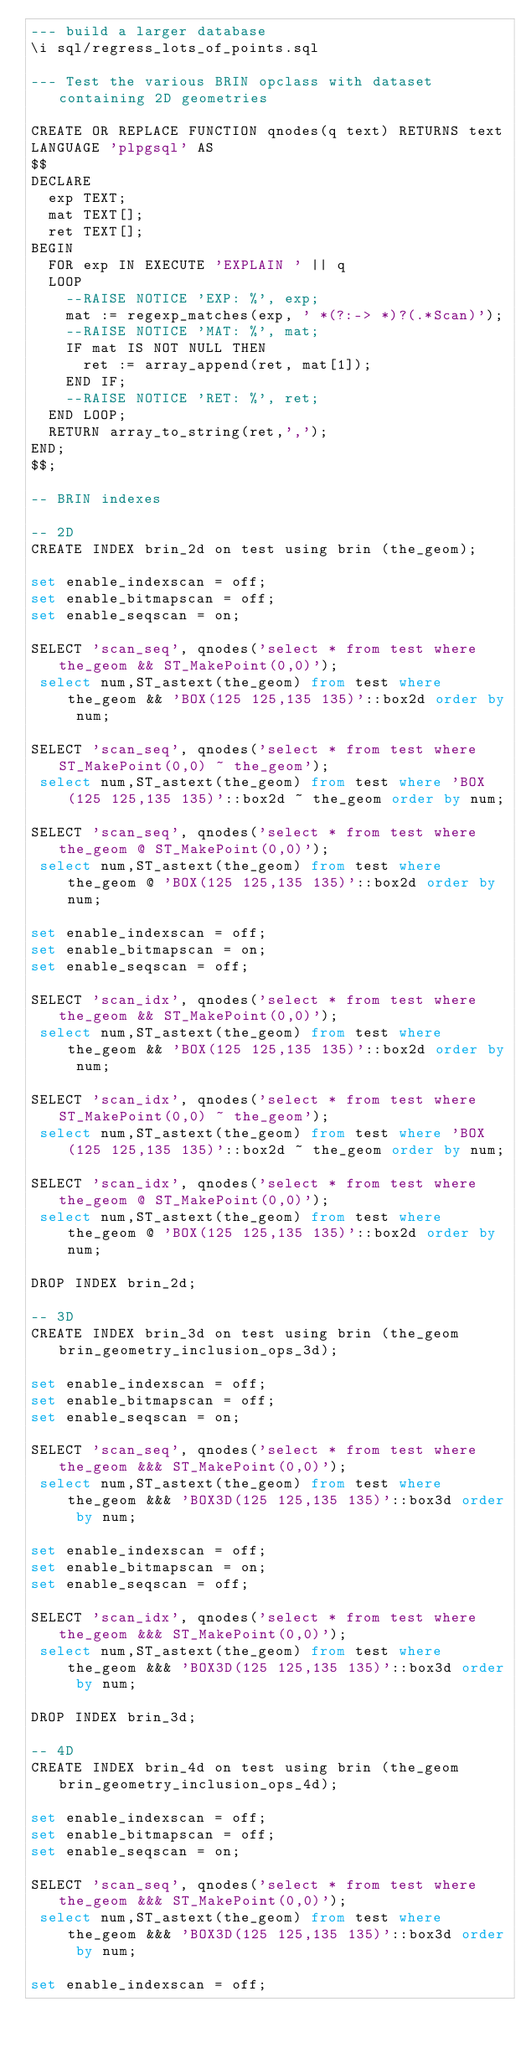<code> <loc_0><loc_0><loc_500><loc_500><_SQL_>--- build a larger database
\i sql/regress_lots_of_points.sql

--- Test the various BRIN opclass with dataset containing 2D geometries

CREATE OR REPLACE FUNCTION qnodes(q text) RETURNS text
LANGUAGE 'plpgsql' AS
$$
DECLARE
  exp TEXT;
  mat TEXT[];
  ret TEXT[];
BEGIN
  FOR exp IN EXECUTE 'EXPLAIN ' || q
  LOOP
    --RAISE NOTICE 'EXP: %', exp;
    mat := regexp_matches(exp, ' *(?:-> *)?(.*Scan)');
    --RAISE NOTICE 'MAT: %', mat;
    IF mat IS NOT NULL THEN
      ret := array_append(ret, mat[1]);
    END IF;
    --RAISE NOTICE 'RET: %', ret;
  END LOOP;
  RETURN array_to_string(ret,',');
END;
$$;

-- BRIN indexes

-- 2D
CREATE INDEX brin_2d on test using brin (the_geom);

set enable_indexscan = off;
set enable_bitmapscan = off;
set enable_seqscan = on;

SELECT 'scan_seq', qnodes('select * from test where the_geom && ST_MakePoint(0,0)');
 select num,ST_astext(the_geom) from test where the_geom && 'BOX(125 125,135 135)'::box2d order by num;

SELECT 'scan_seq', qnodes('select * from test where ST_MakePoint(0,0) ~ the_geom');
 select num,ST_astext(the_geom) from test where 'BOX(125 125,135 135)'::box2d ~ the_geom order by num;

SELECT 'scan_seq', qnodes('select * from test where the_geom @ ST_MakePoint(0,0)');
 select num,ST_astext(the_geom) from test where the_geom @ 'BOX(125 125,135 135)'::box2d order by num;

set enable_indexscan = off;
set enable_bitmapscan = on;
set enable_seqscan = off;

SELECT 'scan_idx', qnodes('select * from test where the_geom && ST_MakePoint(0,0)');
 select num,ST_astext(the_geom) from test where the_geom && 'BOX(125 125,135 135)'::box2d order by num;

SELECT 'scan_idx', qnodes('select * from test where ST_MakePoint(0,0) ~ the_geom');
 select num,ST_astext(the_geom) from test where 'BOX(125 125,135 135)'::box2d ~ the_geom order by num;

SELECT 'scan_idx', qnodes('select * from test where the_geom @ ST_MakePoint(0,0)');
 select num,ST_astext(the_geom) from test where the_geom @ 'BOX(125 125,135 135)'::box2d order by num;

DROP INDEX brin_2d;

-- 3D
CREATE INDEX brin_3d on test using brin (the_geom brin_geometry_inclusion_ops_3d);

set enable_indexscan = off;
set enable_bitmapscan = off;
set enable_seqscan = on;

SELECT 'scan_seq', qnodes('select * from test where the_geom &&& ST_MakePoint(0,0)');
 select num,ST_astext(the_geom) from test where the_geom &&& 'BOX3D(125 125,135 135)'::box3d order by num;

set enable_indexscan = off;
set enable_bitmapscan = on;
set enable_seqscan = off;

SELECT 'scan_idx', qnodes('select * from test where the_geom &&& ST_MakePoint(0,0)');
 select num,ST_astext(the_geom) from test where the_geom &&& 'BOX3D(125 125,135 135)'::box3d order by num;

DROP INDEX brin_3d;

-- 4D
CREATE INDEX brin_4d on test using brin (the_geom brin_geometry_inclusion_ops_4d);

set enable_indexscan = off;
set enable_bitmapscan = off;
set enable_seqscan = on;

SELECT 'scan_seq', qnodes('select * from test where the_geom &&& ST_MakePoint(0,0)');
 select num,ST_astext(the_geom) from test where the_geom &&& 'BOX3D(125 125,135 135)'::box3d order by num;

set enable_indexscan = off;</code> 